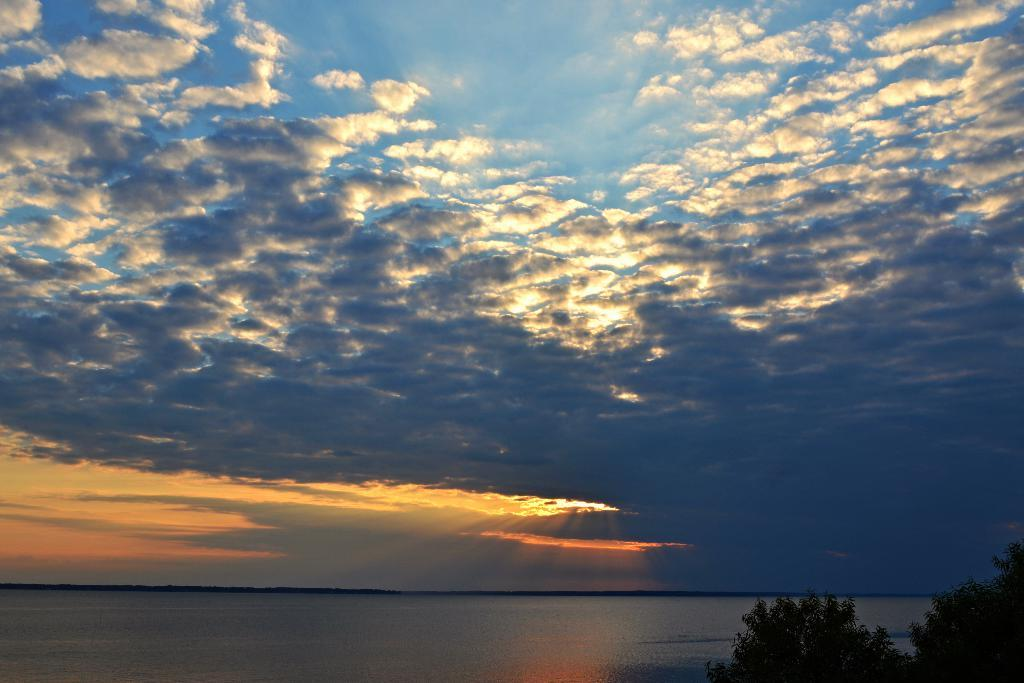What type of vegetation is on the right side of the image? There are trees at the right side of the image. What is located at the center of the image? There is water at the center of the image. What can be seen in the background of the image? The sky is visible in the background of the image. Can you see anyone kicking a ball in the image? There is no ball or person kicking in the image. What type of yarn is being used to create the peace symbol in the image? There is no peace symbol or yarn present in the image. 